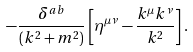<formula> <loc_0><loc_0><loc_500><loc_500>- \frac { \delta ^ { a b } } { ( k ^ { 2 } + m ^ { 2 } ) } \left [ \eta ^ { \mu \nu } - \frac { k ^ { \mu } k ^ { \nu } } { k ^ { 2 } } \right ] .</formula> 